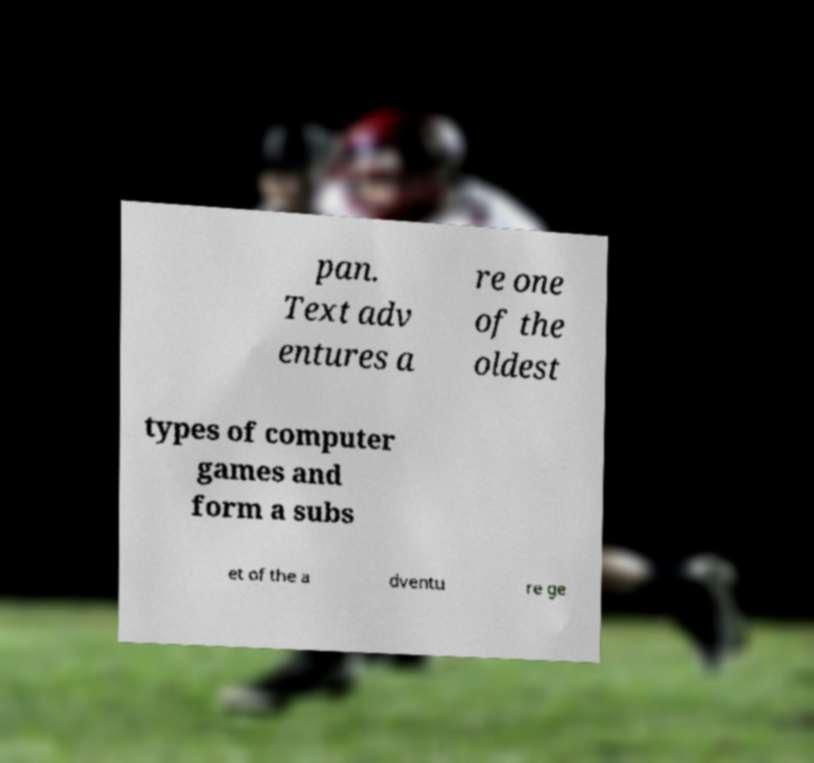Could you extract and type out the text from this image? pan. Text adv entures a re one of the oldest types of computer games and form a subs et of the a dventu re ge 